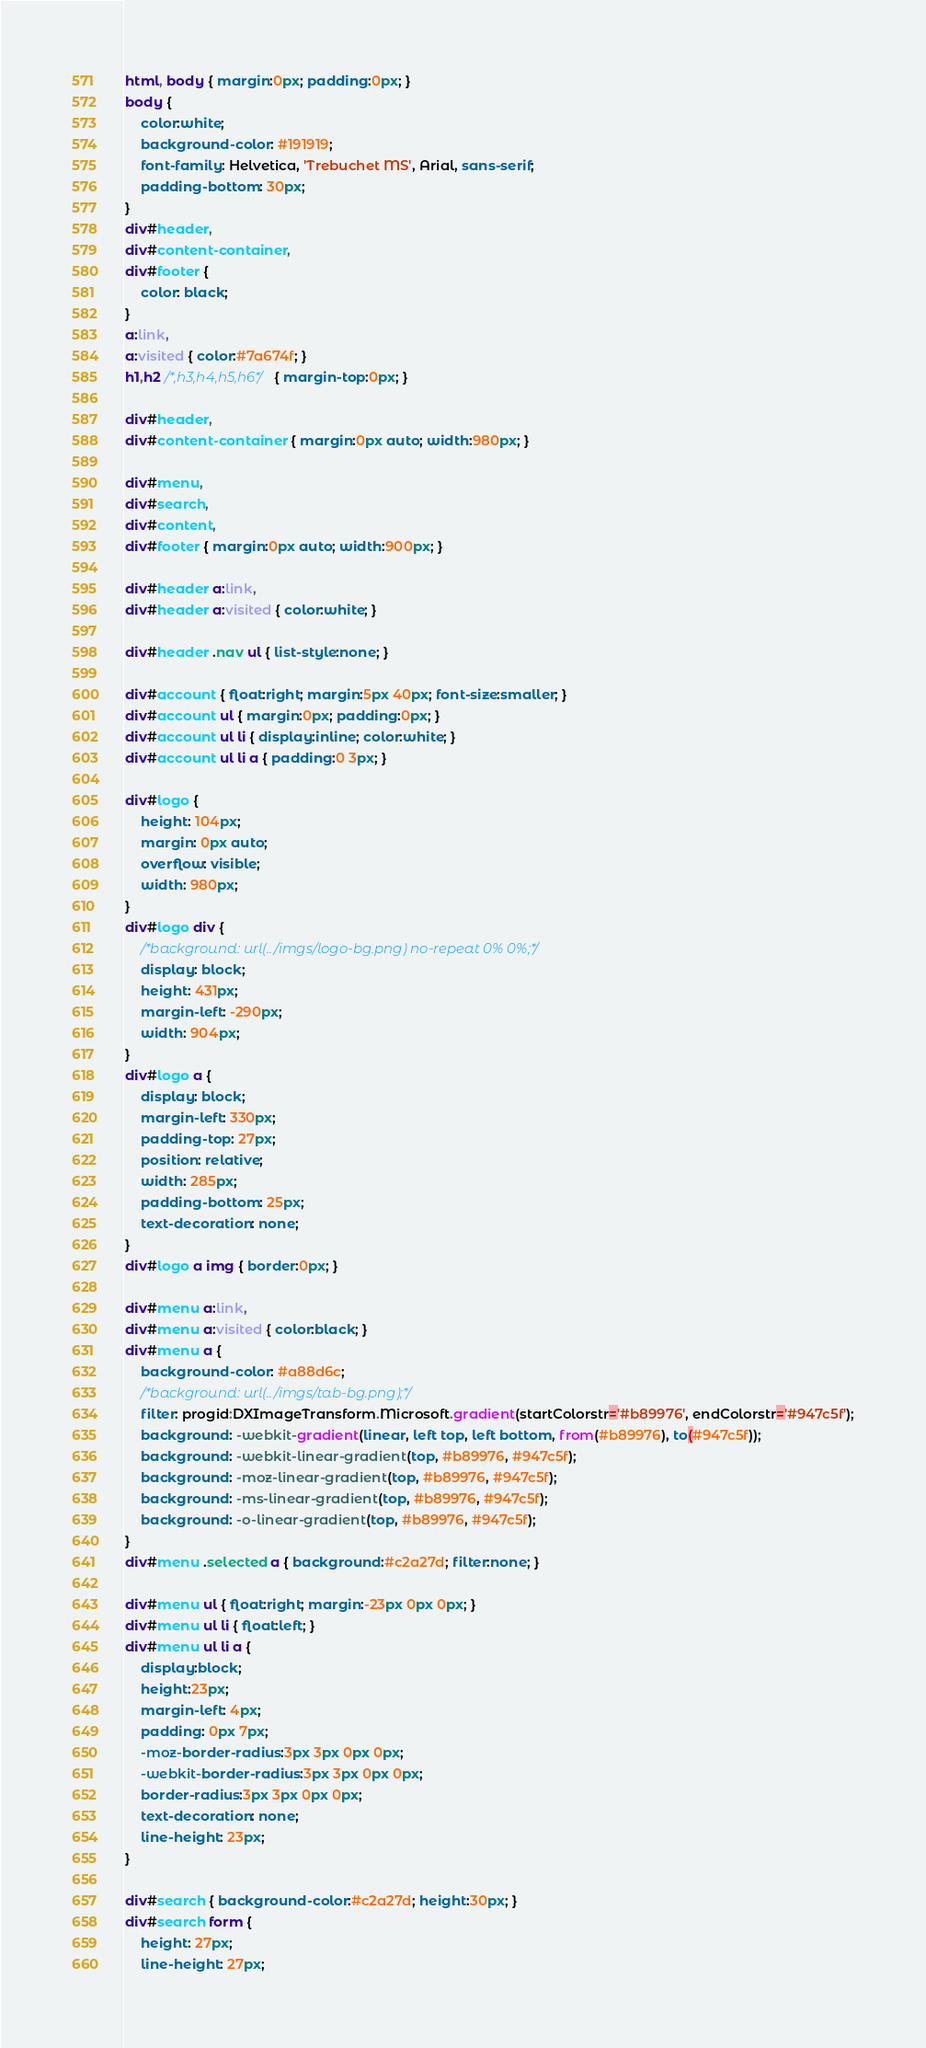<code> <loc_0><loc_0><loc_500><loc_500><_CSS_>html, body { margin:0px; padding:0px; }
body {
    color:white;
    background-color: #191919;
    font-family: Helvetica, 'Trebuchet MS', Arial, sans-serif;
    padding-bottom: 30px;
}
div#header,
div#content-container,
div#footer {
	color: black;
}
a:link,
a:visited { color:#7a674f; }
h1,h2 /*,h3,h4,h5,h6*/ { margin-top:0px; }

div#header,
div#content-container { margin:0px auto; width:980px; }

div#menu,
div#search,
div#content,
div#footer { margin:0px auto; width:900px; }

div#header a:link,
div#header a:visited { color:white; }

div#header .nav ul { list-style:none; }

div#account { float:right; margin:5px 40px; font-size:smaller; }
div#account ul { margin:0px; padding:0px; }
div#account ul li { display:inline; color:white; }
div#account ul li a { padding:0 3px; }

div#logo {
    height: 104px;
    margin: 0px auto;
    overflow: visible;
    width: 980px;
}
div#logo div {
    /*background: url(../imgs/logo-bg.png) no-repeat 0% 0%;*/
    display: block;
    height: 431px;
    margin-left: -290px;
    width: 904px;
}
div#logo a {
    display: block;
    margin-left: 330px;
    padding-top: 27px;
    position: relative;
    width: 285px;
    padding-bottom: 25px;
    text-decoration: none;
}
div#logo a img { border:0px; }

div#menu a:link,
div#menu a:visited { color:black; }
div#menu a {
    background-color: #a88d6c;
    /*background: url(../imgs/tab-bg.png);*/
    filter: progid:DXImageTransform.Microsoft.gradient(startColorstr='#b89976', endColorstr='#947c5f');
    background: -webkit-gradient(linear, left top, left bottom, from(#b89976), to(#947c5f));
    background: -webkit-linear-gradient(top, #b89976, #947c5f);
    background: -moz-linear-gradient(top, #b89976, #947c5f);
    background: -ms-linear-gradient(top, #b89976, #947c5f);
    background: -o-linear-gradient(top, #b89976, #947c5f);
}
div#menu .selected a { background:#c2a27d; filter:none; }

div#menu ul { float:right; margin:-23px 0px 0px; }
div#menu ul li { float:left; }
div#menu ul li a {
    display:block;
    height:23px;
    margin-left: 4px;
    padding: 0px 7px;
    -moz-border-radius:3px 3px 0px 0px;
    -webkit-border-radius:3px 3px 0px 0px;
    border-radius:3px 3px 0px 0px;
    text-decoration: none;
    line-height: 23px;
}

div#search { background-color:#c2a27d; height:30px; }
div#search form {
    height: 27px;
    line-height: 27px;</code> 